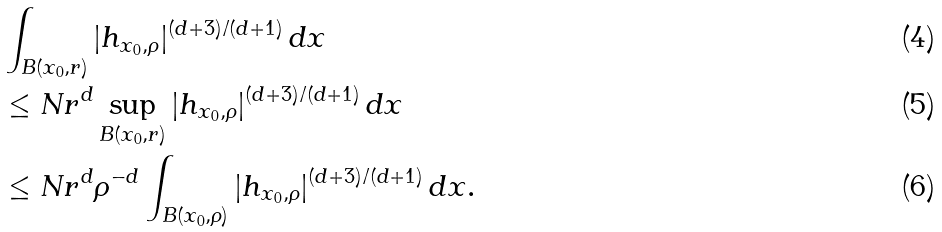Convert formula to latex. <formula><loc_0><loc_0><loc_500><loc_500>& \int _ { B ( x _ { 0 } , r ) } | h _ { x _ { 0 } , \rho } | ^ { ( d + 3 ) / ( d + 1 ) } \, d x \\ & \leq N r ^ { d } \sup _ { B ( x _ { 0 } , r ) } | h _ { x _ { 0 } , \rho } | ^ { ( d + 3 ) / ( d + 1 ) } \, d x \\ & \leq N r ^ { d } \rho ^ { - d } \int _ { B ( x _ { 0 } , \rho ) } | h _ { x _ { 0 } , \rho } | ^ { ( d + 3 ) / ( d + 1 ) } \, d x .</formula> 